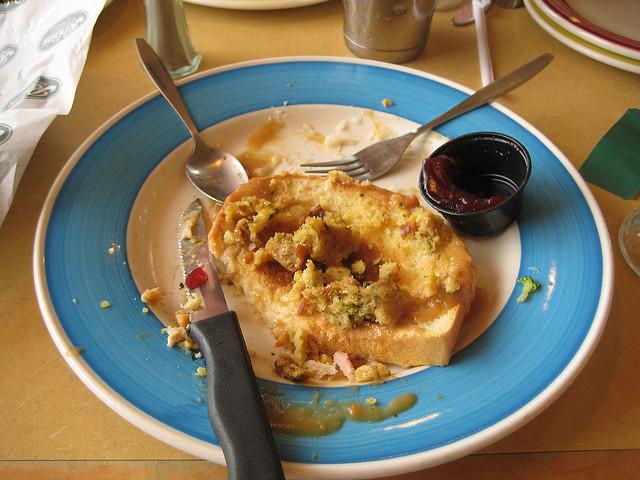What type of utensils are pictured?
Short answer required. Knife, fork, spoon. Is anybody going to finish this food?
Concise answer only. No. What vegetable does the tiny green food scrap on the right side come from?
Write a very short answer. Broccoli. 